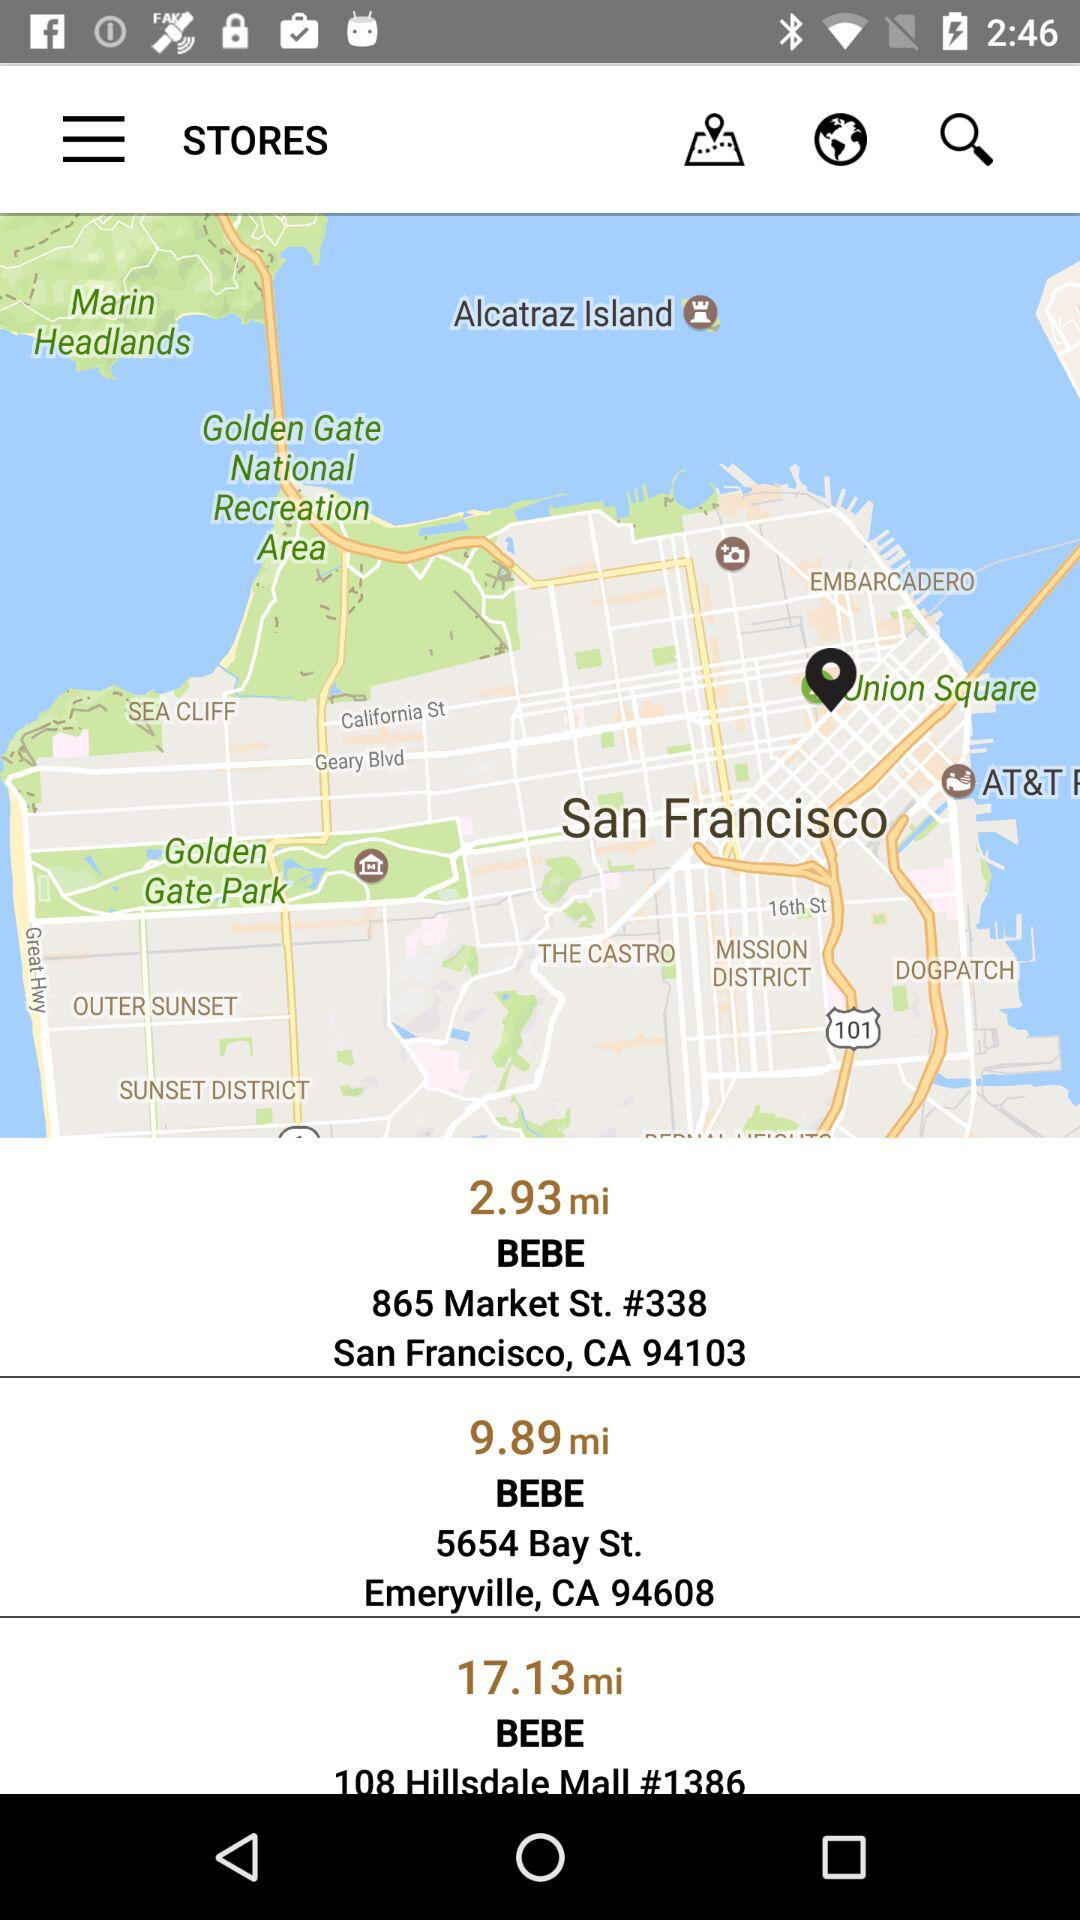What is the address of the BEBE store with pincode 94103? The address of the BEBE store with pincode 94103 is 865 Market St., #338, San Francisco, CA. 